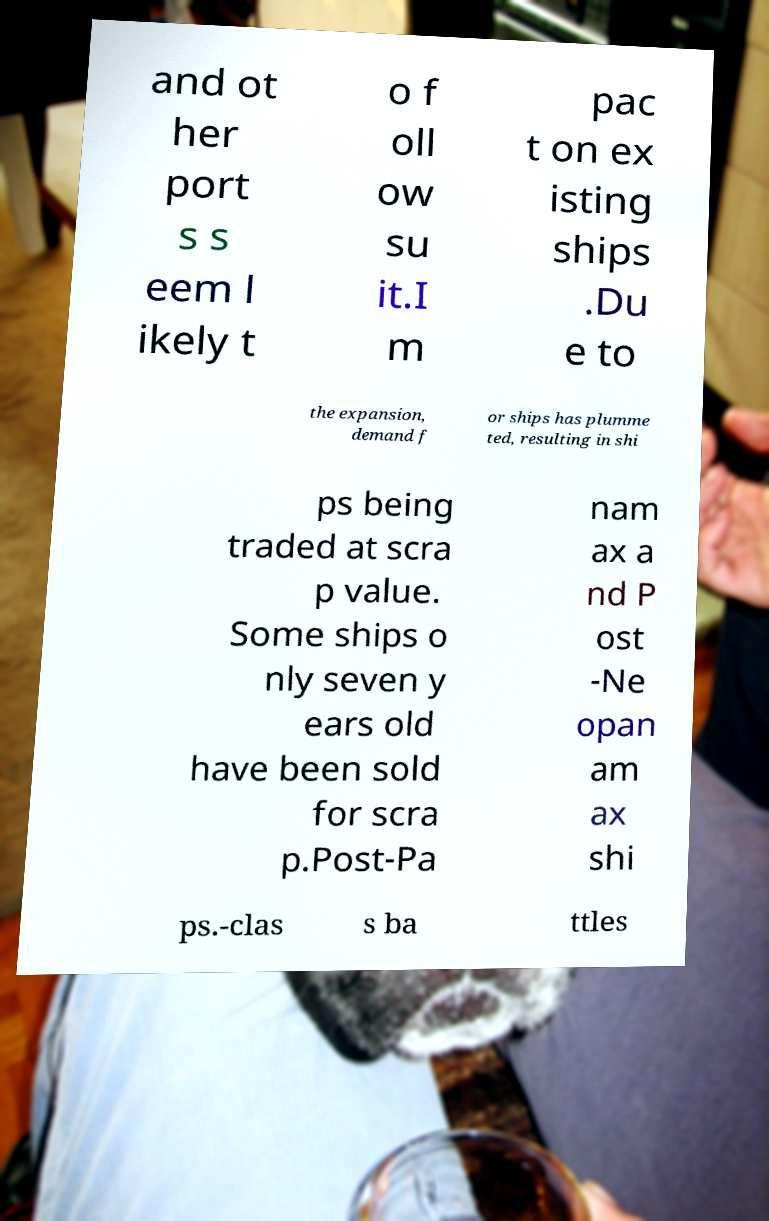I need the written content from this picture converted into text. Can you do that? and ot her port s s eem l ikely t o f oll ow su it.I m pac t on ex isting ships .Du e to the expansion, demand f or ships has plumme ted, resulting in shi ps being traded at scra p value. Some ships o nly seven y ears old have been sold for scra p.Post-Pa nam ax a nd P ost -Ne opan am ax shi ps.-clas s ba ttles 